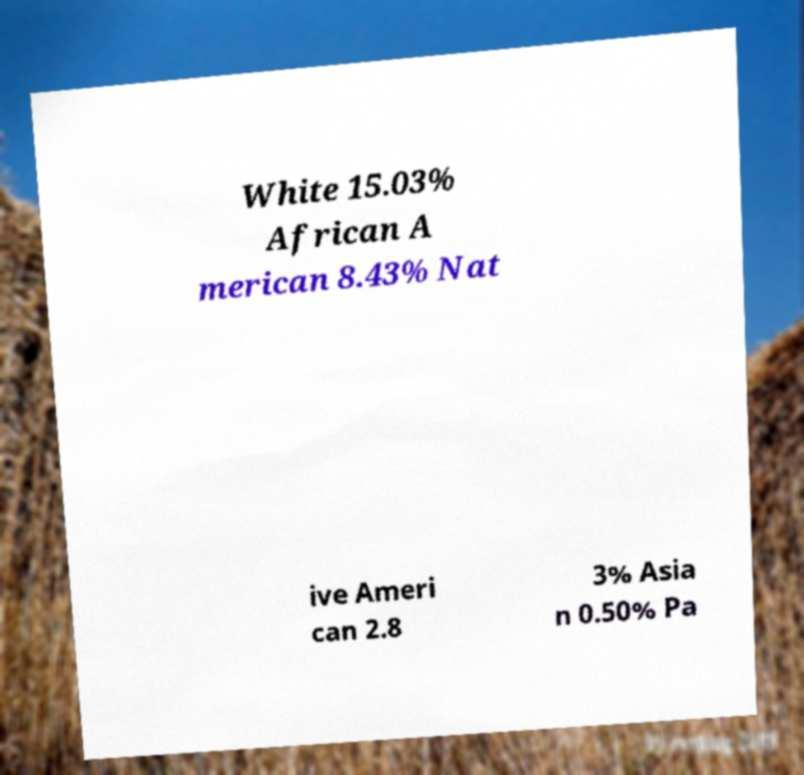Please read and relay the text visible in this image. What does it say? White 15.03% African A merican 8.43% Nat ive Ameri can 2.8 3% Asia n 0.50% Pa 